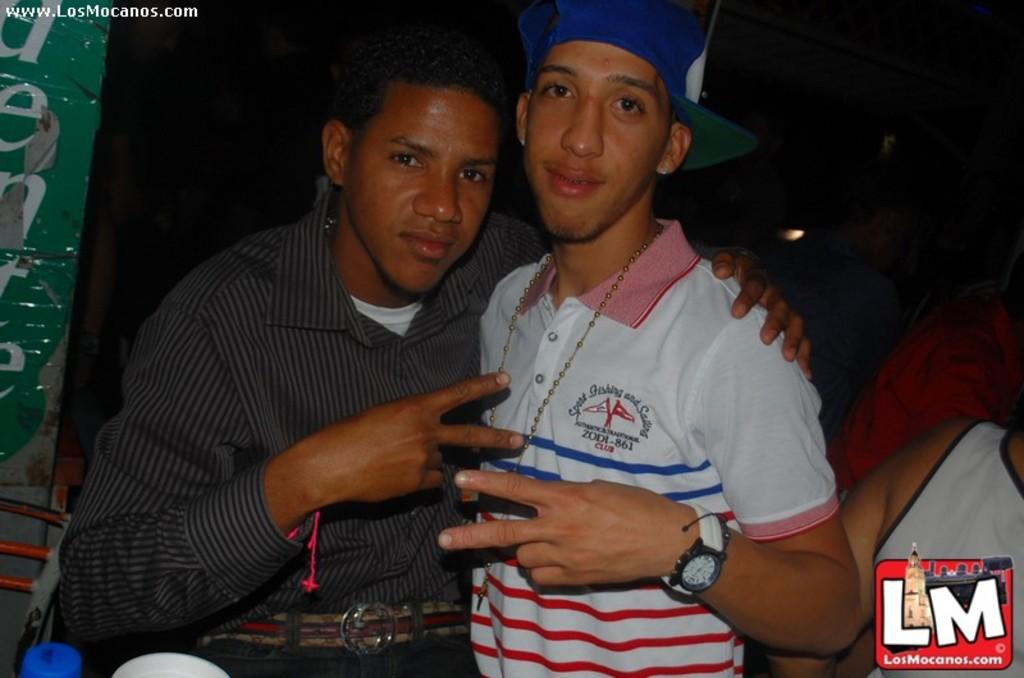<image>
Offer a succinct explanation of the picture presented. Sport Fishing and Sailing is the logo on the teen's shirt with the blue baseball cap. 